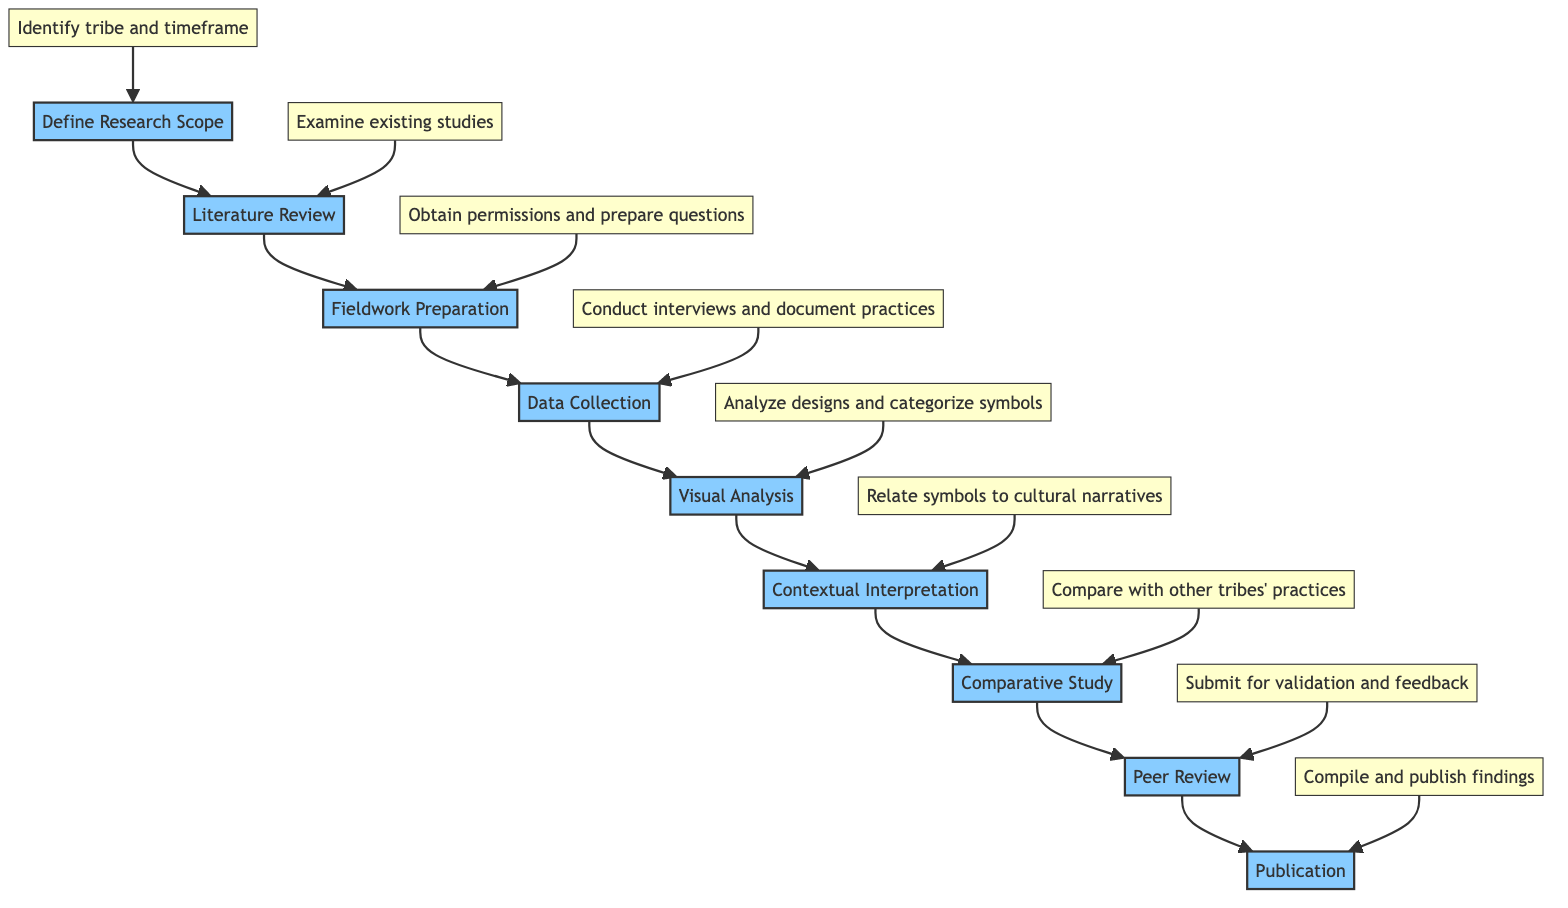What is the first step in the analysis process? The diagram shows that the first step is "Define Research Scope." This is indicated as the starting node in the flowchart, leading to the next step.
Answer: Define Research Scope How many steps are there in total? By counting the nodes in the diagram, there are a total of nine main steps listed, from "Define Research Scope" to "Publication."
Answer: 9 What is the last step in the flowchart? The final node in the flowchart is "Publication," which is the concluding step after all preceding steps have been completed.
Answer: Publication Which step follows "Data Collection"? After "Data Collection," the next step indicated in the flowchart is "Visual Analysis." This can be identified by tracing the arrow from "Data Collection."
Answer: Visual Analysis What are the two main components of "Fieldwork Preparation"? The details associated with "Fieldwork Preparation" specify "Obtain necessary permissions for fieldwork" and "prepare interview questions and survey forms." These components highlight the preparations for conducting field research.
Answer: Obtain permissions and prepare questions How does "Comparative Study" relate to previous steps? The "Comparative Study" step follows "Contextual Interpretation." This indicates that it builds on the findings and interpretations made in the previous steps to draw comparisons with other tribes' tattoo practices.
Answer: Follows Contextual Interpretation What is emphasized as important during "Fieldwork Preparation"? The diagram details that "Ensure cultural sensitivity training" is essential during the "Fieldwork Preparation" step, highlighting the importance of respecting indigenous cultures.
Answer: Cultural sensitivity training What type of expert feedback is involved in the "Peer Review" step? The "Peer Review" step involves submitting findings to "academic peers and local cultural experts," indicating that it requires validation and feedback from knowledgeable individuals in the field.
Answer: Academic peers and cultural experts What tools may be used in the "Visual Analysis"? The diagram suggests using "Adobe Illustrator for digital mapping" in the "Visual Analysis" step, which shows the need for software support in analyzing tattoo designs.
Answer: Adobe Illustrator 